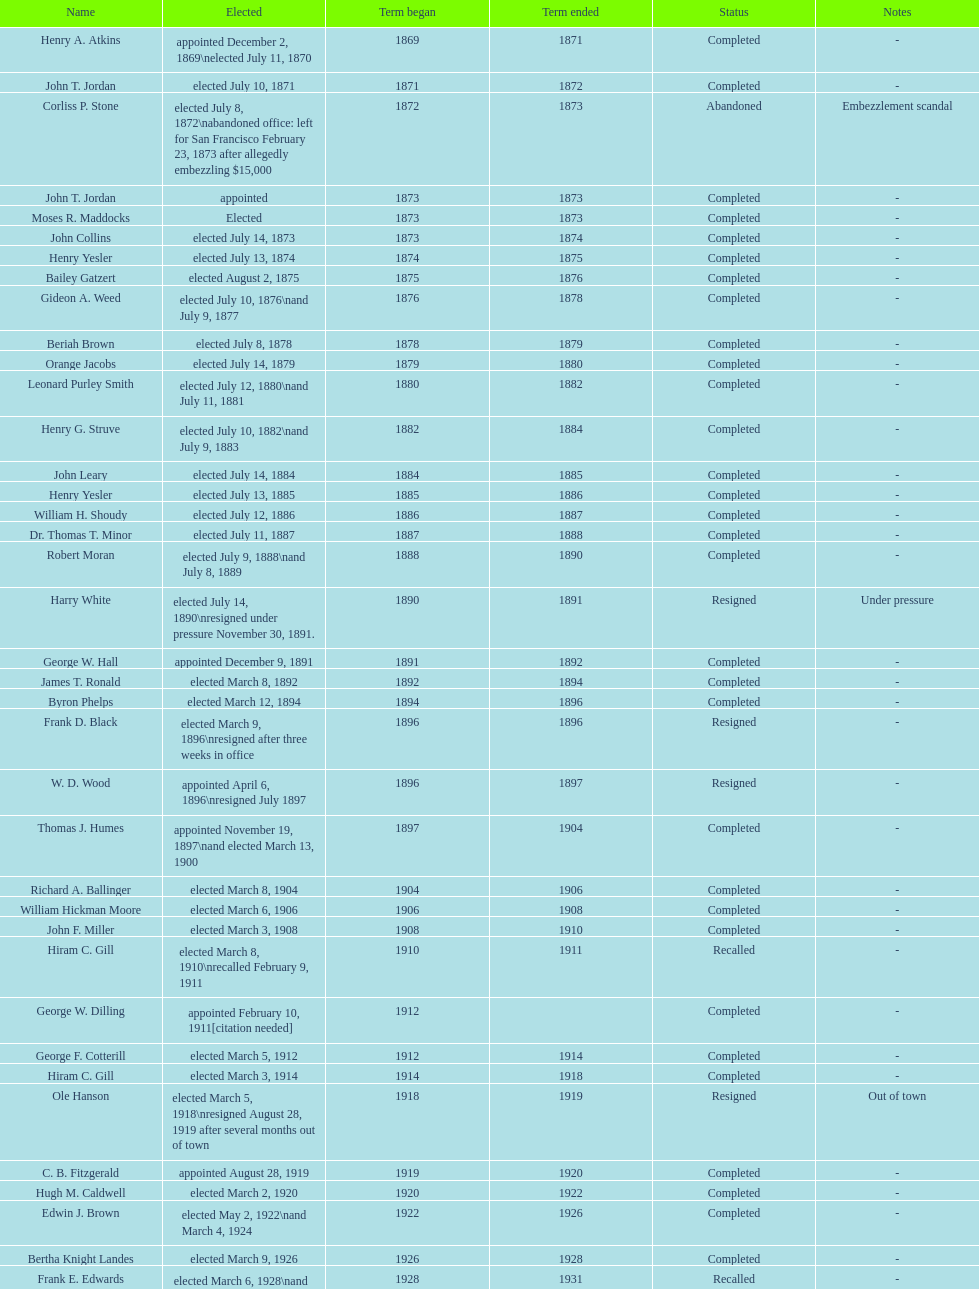Who was the only person elected in 1871? John T. Jordan. 